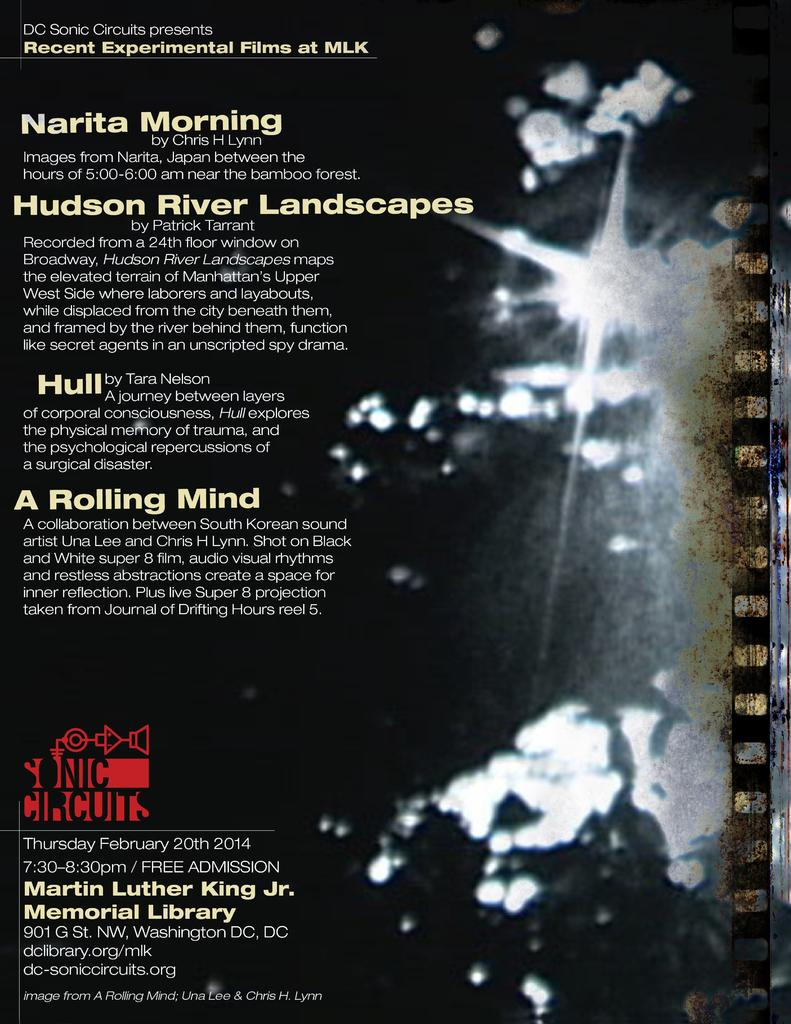<image>
Create a compact narrative representing the image presented. Sonic circuits advertisement poster for an event being held at the Martin Luther King Jr. Memorial Library. 